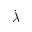Convert formula to latex. <formula><loc_0><loc_0><loc_500><loc_500>\dot { \lambda }</formula> 